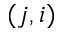Convert formula to latex. <formula><loc_0><loc_0><loc_500><loc_500>( j , i )</formula> 